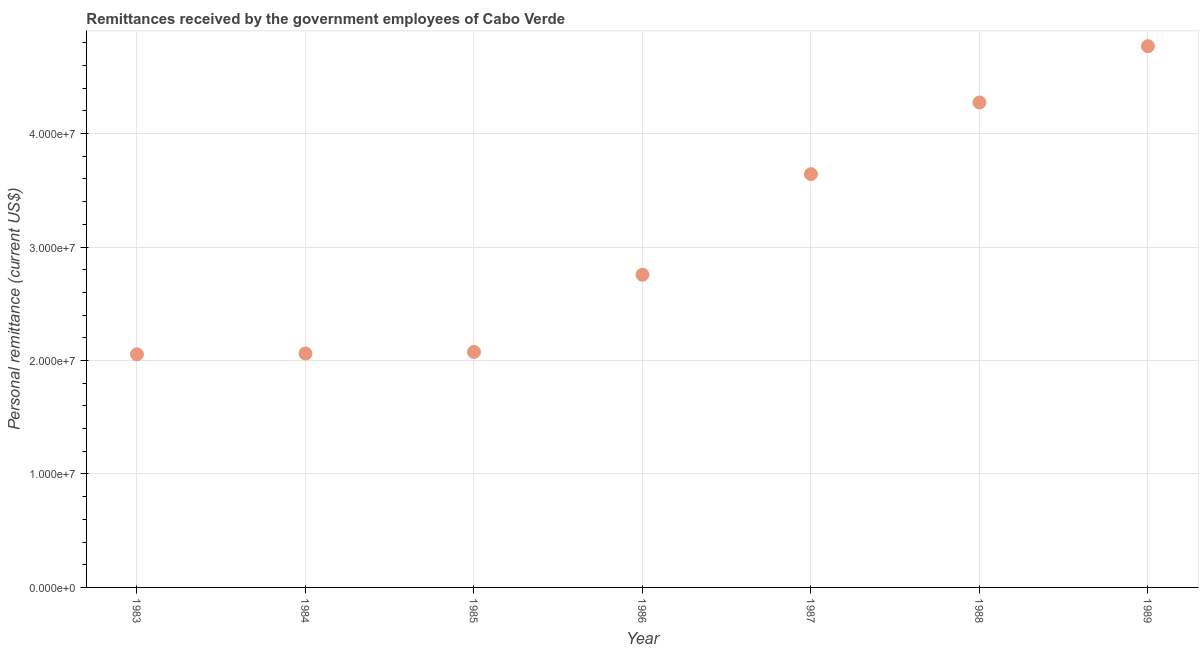What is the personal remittances in 1984?
Provide a succinct answer. 2.06e+07. Across all years, what is the maximum personal remittances?
Offer a very short reply. 4.77e+07. Across all years, what is the minimum personal remittances?
Your response must be concise. 2.05e+07. In which year was the personal remittances maximum?
Make the answer very short. 1989. What is the sum of the personal remittances?
Your answer should be very brief. 2.16e+08. What is the difference between the personal remittances in 1986 and 1988?
Offer a very short reply. -1.52e+07. What is the average personal remittances per year?
Offer a very short reply. 3.09e+07. What is the median personal remittances?
Offer a very short reply. 2.76e+07. What is the ratio of the personal remittances in 1985 to that in 1989?
Offer a terse response. 0.44. Is the personal remittances in 1985 less than that in 1989?
Offer a terse response. Yes. What is the difference between the highest and the second highest personal remittances?
Provide a short and direct response. 4.96e+06. What is the difference between the highest and the lowest personal remittances?
Make the answer very short. 2.72e+07. In how many years, is the personal remittances greater than the average personal remittances taken over all years?
Your response must be concise. 3. What is the difference between two consecutive major ticks on the Y-axis?
Offer a terse response. 1.00e+07. Does the graph contain grids?
Your answer should be very brief. Yes. What is the title of the graph?
Your answer should be compact. Remittances received by the government employees of Cabo Verde. What is the label or title of the X-axis?
Your answer should be compact. Year. What is the label or title of the Y-axis?
Ensure brevity in your answer.  Personal remittance (current US$). What is the Personal remittance (current US$) in 1983?
Ensure brevity in your answer.  2.05e+07. What is the Personal remittance (current US$) in 1984?
Offer a terse response. 2.06e+07. What is the Personal remittance (current US$) in 1985?
Your answer should be compact. 2.08e+07. What is the Personal remittance (current US$) in 1986?
Ensure brevity in your answer.  2.76e+07. What is the Personal remittance (current US$) in 1987?
Make the answer very short. 3.64e+07. What is the Personal remittance (current US$) in 1988?
Offer a terse response. 4.27e+07. What is the Personal remittance (current US$) in 1989?
Offer a very short reply. 4.77e+07. What is the difference between the Personal remittance (current US$) in 1983 and 1984?
Your answer should be compact. -6.99e+04. What is the difference between the Personal remittance (current US$) in 1983 and 1985?
Your response must be concise. -2.09e+05. What is the difference between the Personal remittance (current US$) in 1983 and 1986?
Keep it short and to the point. -7.01e+06. What is the difference between the Personal remittance (current US$) in 1983 and 1987?
Provide a succinct answer. -1.59e+07. What is the difference between the Personal remittance (current US$) in 1983 and 1988?
Offer a very short reply. -2.22e+07. What is the difference between the Personal remittance (current US$) in 1983 and 1989?
Your answer should be very brief. -2.72e+07. What is the difference between the Personal remittance (current US$) in 1984 and 1985?
Make the answer very short. -1.39e+05. What is the difference between the Personal remittance (current US$) in 1984 and 1986?
Offer a terse response. -6.94e+06. What is the difference between the Personal remittance (current US$) in 1984 and 1987?
Your answer should be compact. -1.58e+07. What is the difference between the Personal remittance (current US$) in 1984 and 1988?
Offer a very short reply. -2.21e+07. What is the difference between the Personal remittance (current US$) in 1984 and 1989?
Your answer should be very brief. -2.71e+07. What is the difference between the Personal remittance (current US$) in 1985 and 1986?
Your answer should be very brief. -6.80e+06. What is the difference between the Personal remittance (current US$) in 1985 and 1987?
Provide a succinct answer. -1.57e+07. What is the difference between the Personal remittance (current US$) in 1985 and 1988?
Provide a succinct answer. -2.20e+07. What is the difference between the Personal remittance (current US$) in 1985 and 1989?
Provide a succinct answer. -2.69e+07. What is the difference between the Personal remittance (current US$) in 1986 and 1987?
Your answer should be very brief. -8.87e+06. What is the difference between the Personal remittance (current US$) in 1986 and 1988?
Your answer should be compact. -1.52e+07. What is the difference between the Personal remittance (current US$) in 1986 and 1989?
Offer a terse response. -2.01e+07. What is the difference between the Personal remittance (current US$) in 1987 and 1988?
Ensure brevity in your answer.  -6.32e+06. What is the difference between the Personal remittance (current US$) in 1987 and 1989?
Make the answer very short. -1.13e+07. What is the difference between the Personal remittance (current US$) in 1988 and 1989?
Provide a succinct answer. -4.96e+06. What is the ratio of the Personal remittance (current US$) in 1983 to that in 1985?
Your answer should be compact. 0.99. What is the ratio of the Personal remittance (current US$) in 1983 to that in 1986?
Ensure brevity in your answer.  0.75. What is the ratio of the Personal remittance (current US$) in 1983 to that in 1987?
Give a very brief answer. 0.56. What is the ratio of the Personal remittance (current US$) in 1983 to that in 1988?
Offer a terse response. 0.48. What is the ratio of the Personal remittance (current US$) in 1983 to that in 1989?
Give a very brief answer. 0.43. What is the ratio of the Personal remittance (current US$) in 1984 to that in 1985?
Make the answer very short. 0.99. What is the ratio of the Personal remittance (current US$) in 1984 to that in 1986?
Ensure brevity in your answer.  0.75. What is the ratio of the Personal remittance (current US$) in 1984 to that in 1987?
Ensure brevity in your answer.  0.57. What is the ratio of the Personal remittance (current US$) in 1984 to that in 1988?
Make the answer very short. 0.48. What is the ratio of the Personal remittance (current US$) in 1984 to that in 1989?
Give a very brief answer. 0.43. What is the ratio of the Personal remittance (current US$) in 1985 to that in 1986?
Provide a short and direct response. 0.75. What is the ratio of the Personal remittance (current US$) in 1985 to that in 1987?
Give a very brief answer. 0.57. What is the ratio of the Personal remittance (current US$) in 1985 to that in 1988?
Your answer should be very brief. 0.49. What is the ratio of the Personal remittance (current US$) in 1985 to that in 1989?
Make the answer very short. 0.43. What is the ratio of the Personal remittance (current US$) in 1986 to that in 1987?
Your answer should be compact. 0.76. What is the ratio of the Personal remittance (current US$) in 1986 to that in 1988?
Give a very brief answer. 0.65. What is the ratio of the Personal remittance (current US$) in 1986 to that in 1989?
Ensure brevity in your answer.  0.58. What is the ratio of the Personal remittance (current US$) in 1987 to that in 1988?
Your answer should be compact. 0.85. What is the ratio of the Personal remittance (current US$) in 1987 to that in 1989?
Give a very brief answer. 0.76. What is the ratio of the Personal remittance (current US$) in 1988 to that in 1989?
Give a very brief answer. 0.9. 